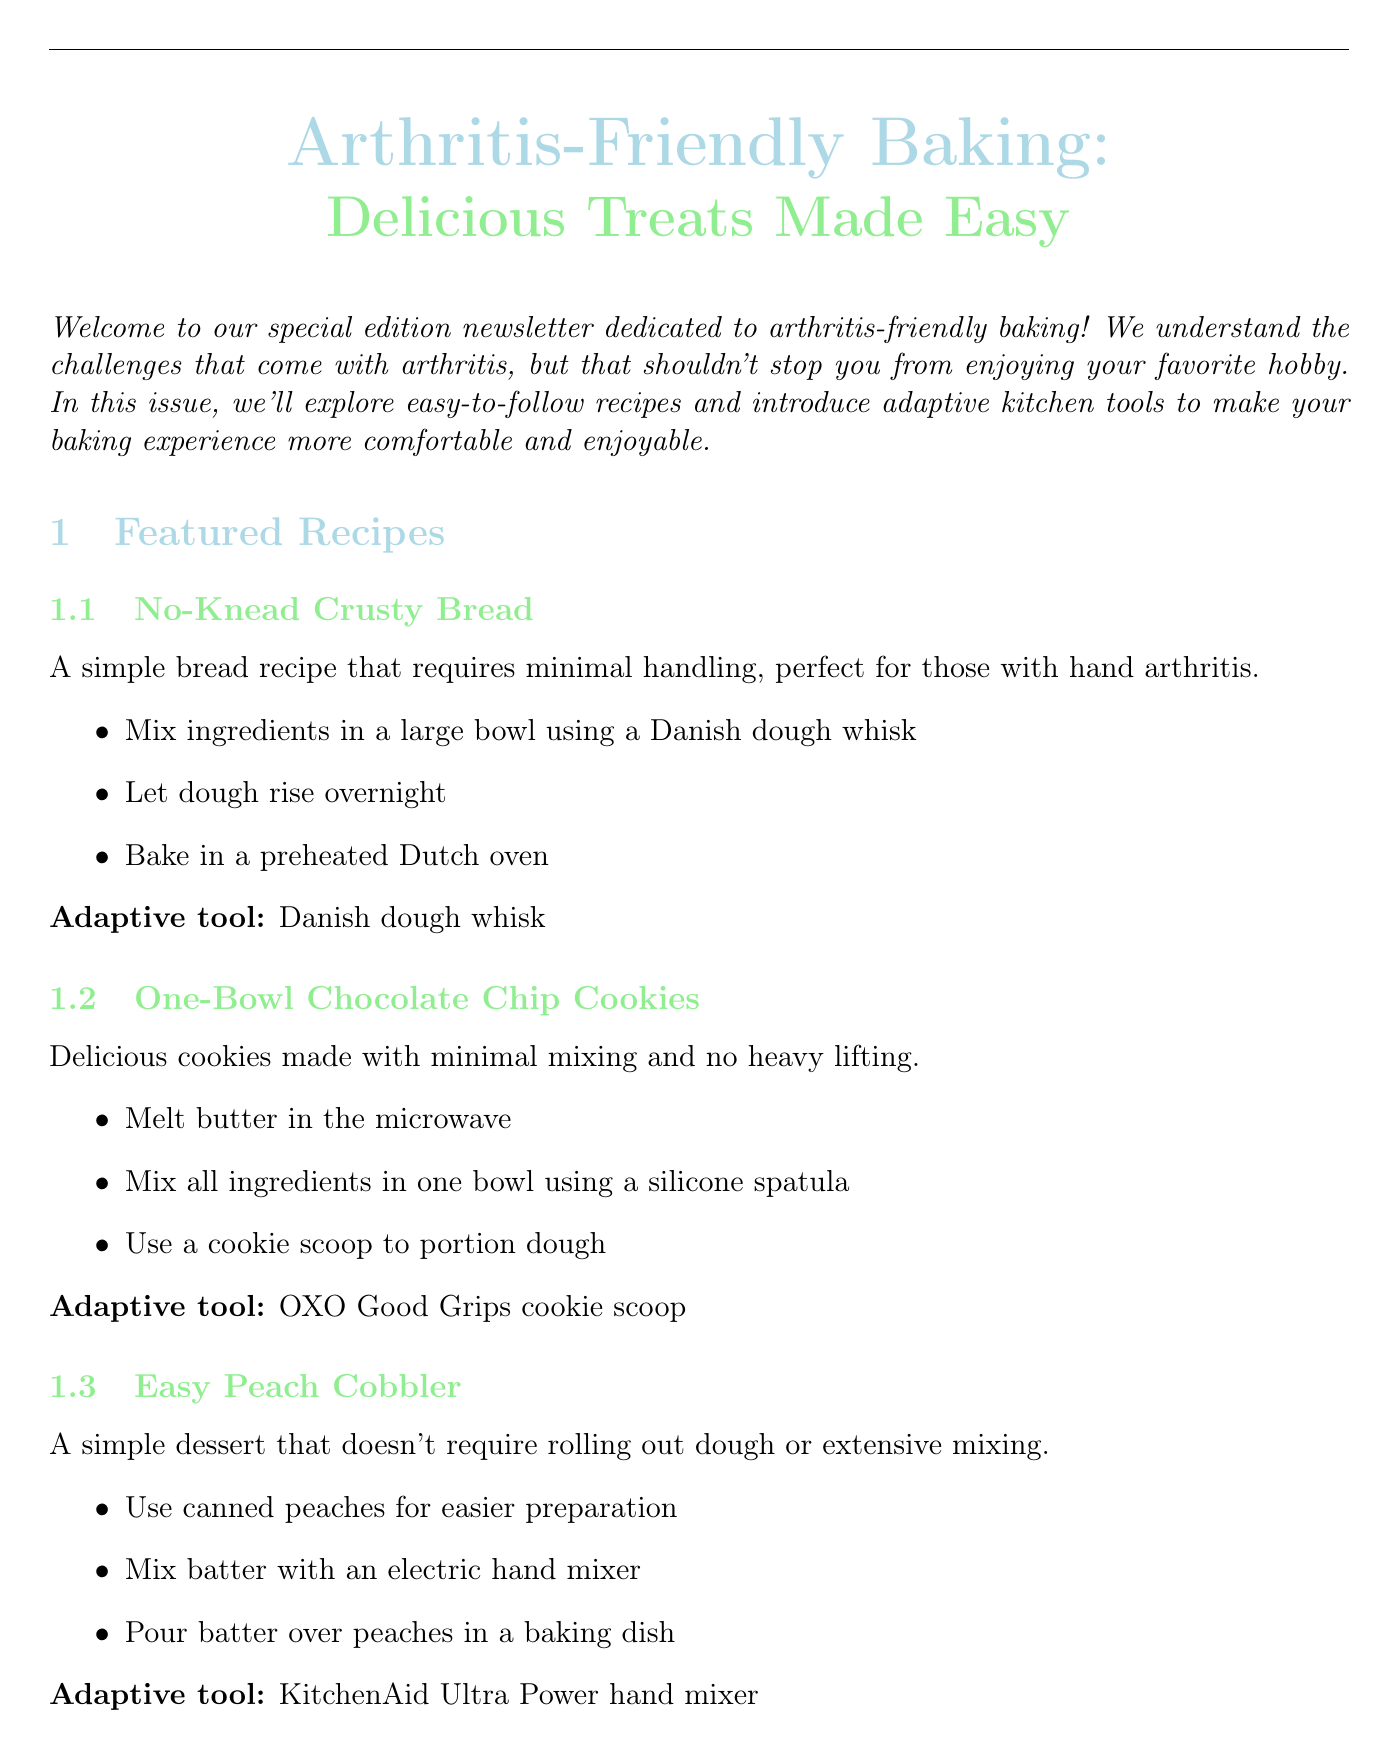What is the title of the newsletter? The title is stated at the beginning of the document, presenting the theme of the newsletter.
Answer: Arthritis-Friendly Baking: Delicious Treats Made Easy Who is the featured baker interviewed in the newsletter? The document contains an interview section that highlights a specific baker's story.
Answer: Margaret Thompson What is one recipe featured in this newsletter? The newsletter lists several recipes under the featured recipes section.
Answer: No-Knead Crusty Bread What date is the Virtual Arthritis-Friendly Baking Workshop scheduled for? The upcoming events section specifies the date for the baking workshop.
Answer: July 15, 2023 Which adaptive tool is recommended for mixing dough? The spotlight on adaptive kitchen tools mentions several tools and their uses.
Answer: KitchenAid Stand Mixer How many years of baking experience does Margaret Thompson have? Margaret's experience is noted in the interview section of the newsletter.
Answer: 50 years What is a benefit of the OXO Good Grips Baking Tools? The benefits of various kitchen tools are outlined in their respective descriptions.
Answer: Easier gripping What does the Easy Peach Cobbler recipe use for easier preparation? The key steps of the recipe indicate how to simplify the preparation process.
Answer: Canned peaches What is one baking tip mentioned for those with arthritis? The document includes a specific section listing helpful tips for arthritis-friendly baking.
Answer: Prepare ingredients in advance 